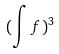Convert formula to latex. <formula><loc_0><loc_0><loc_500><loc_500>( \int f ) ^ { 3 }</formula> 